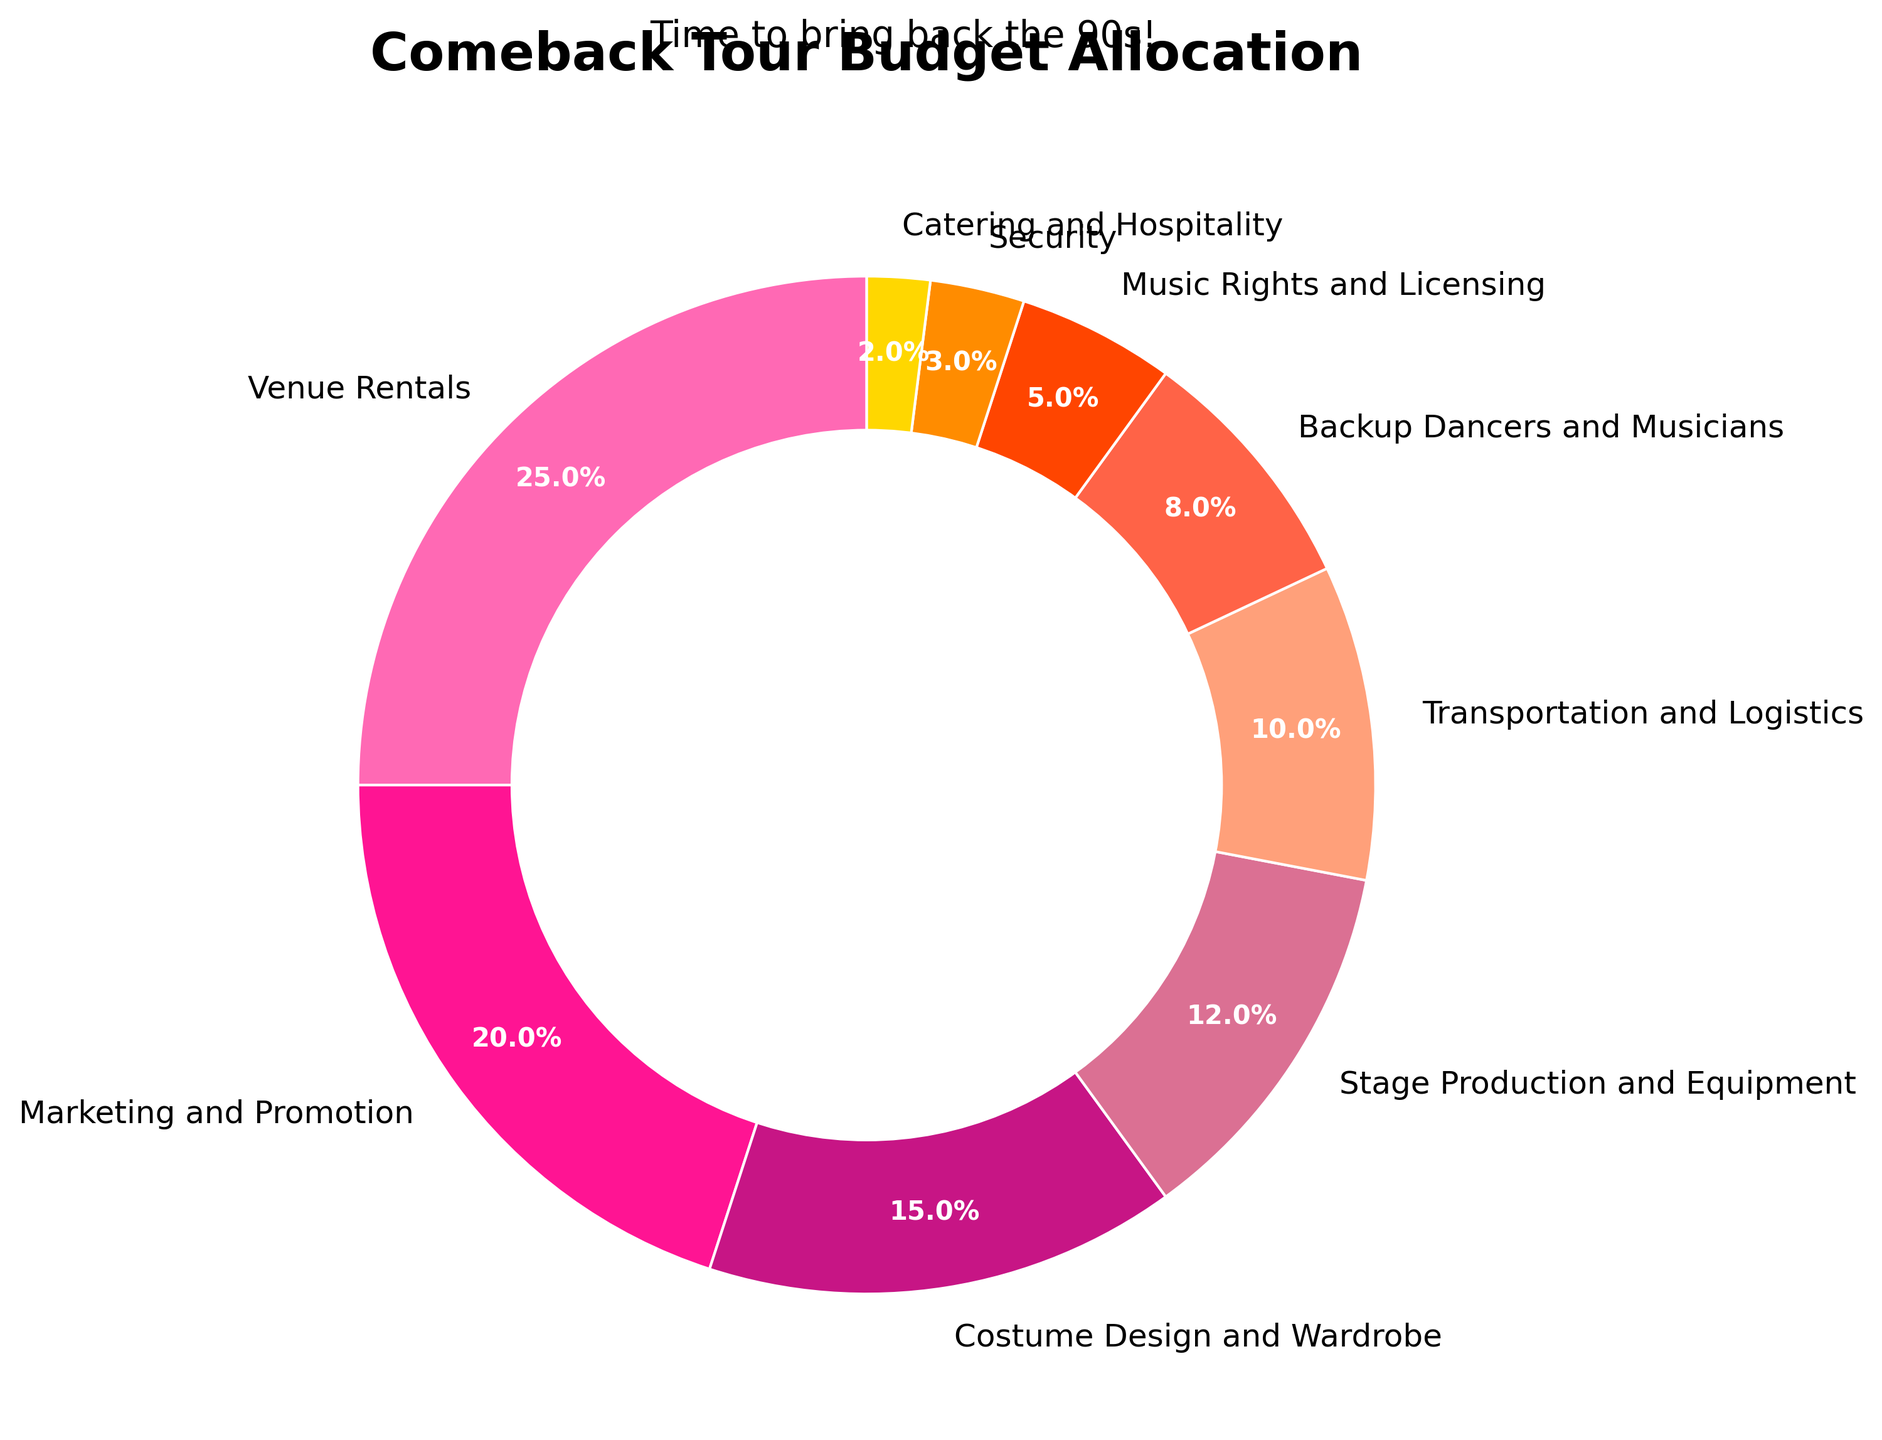What percentage of the budget is allocated to costume design and wardrobe and stage production and equipment combined? Add the percentage for costume design and wardrobe (15%) to the percentage for stage production and equipment (12%). 15% + 12% = 27%
Answer: 27% Which category has the smallest allocation and what is its percentage? The smallest allocation can be found by identifying the smallest slice in the pie chart, which is "Catering and Hospitality" at 2%.
Answer: Catering and Hospitality, 2% Is the budget for marketing and promotion greater than the budget for transportation and logistics? Compare the percentages for marketing and promotion (20%) and transportation and logistics (10%). 20% is greater than 10%.
Answer: Yes How much more budget is allocated to venue rentals than to music rights and licensing? Subtract the percentage for music rights and licensing (5%) from the percentage for venue rentals (25%). 25% - 5% = 20%
Answer: 20% Which two categories have the same color, and what are those categories? Look at the pie chart and identify the wedges that share the same color. None of the categories have the same color in the given data.
Answer: None What's the total percentage allocated to backup dancers and musicians and security? Add the percentages for backup dancers and musicians (8%) and security (3%). 8% + 3% = 11%
Answer: 11% What is the combined percentage of all categories except venue rentals? Subtract the percentage for venue rentals (25%) from 100%. 100% - 25% = 75%
Answer: 75% Which category has the highest percentage, and what is its exact value? Identify the largest slice in the pie chart, which is "Venue Rentals" at 25%.
Answer: Venue Rentals, 25% Is stage production and equipment's budget allocation more or less compared to backup dancers and musicians? By how much? Compare the percentages for stage production and equipment (12%) and backup dancers and musicians (8%) and find the difference. 12% - 8% = 4%
Answer: More, by 4% How much more budget is allocated to marketing and promotion than to catering and hospitality? Subtract the percentage for catering and hospitality (2%) from the percentage for marketing and promotion (20%). 20% - 2% = 18%
Answer: 18% 